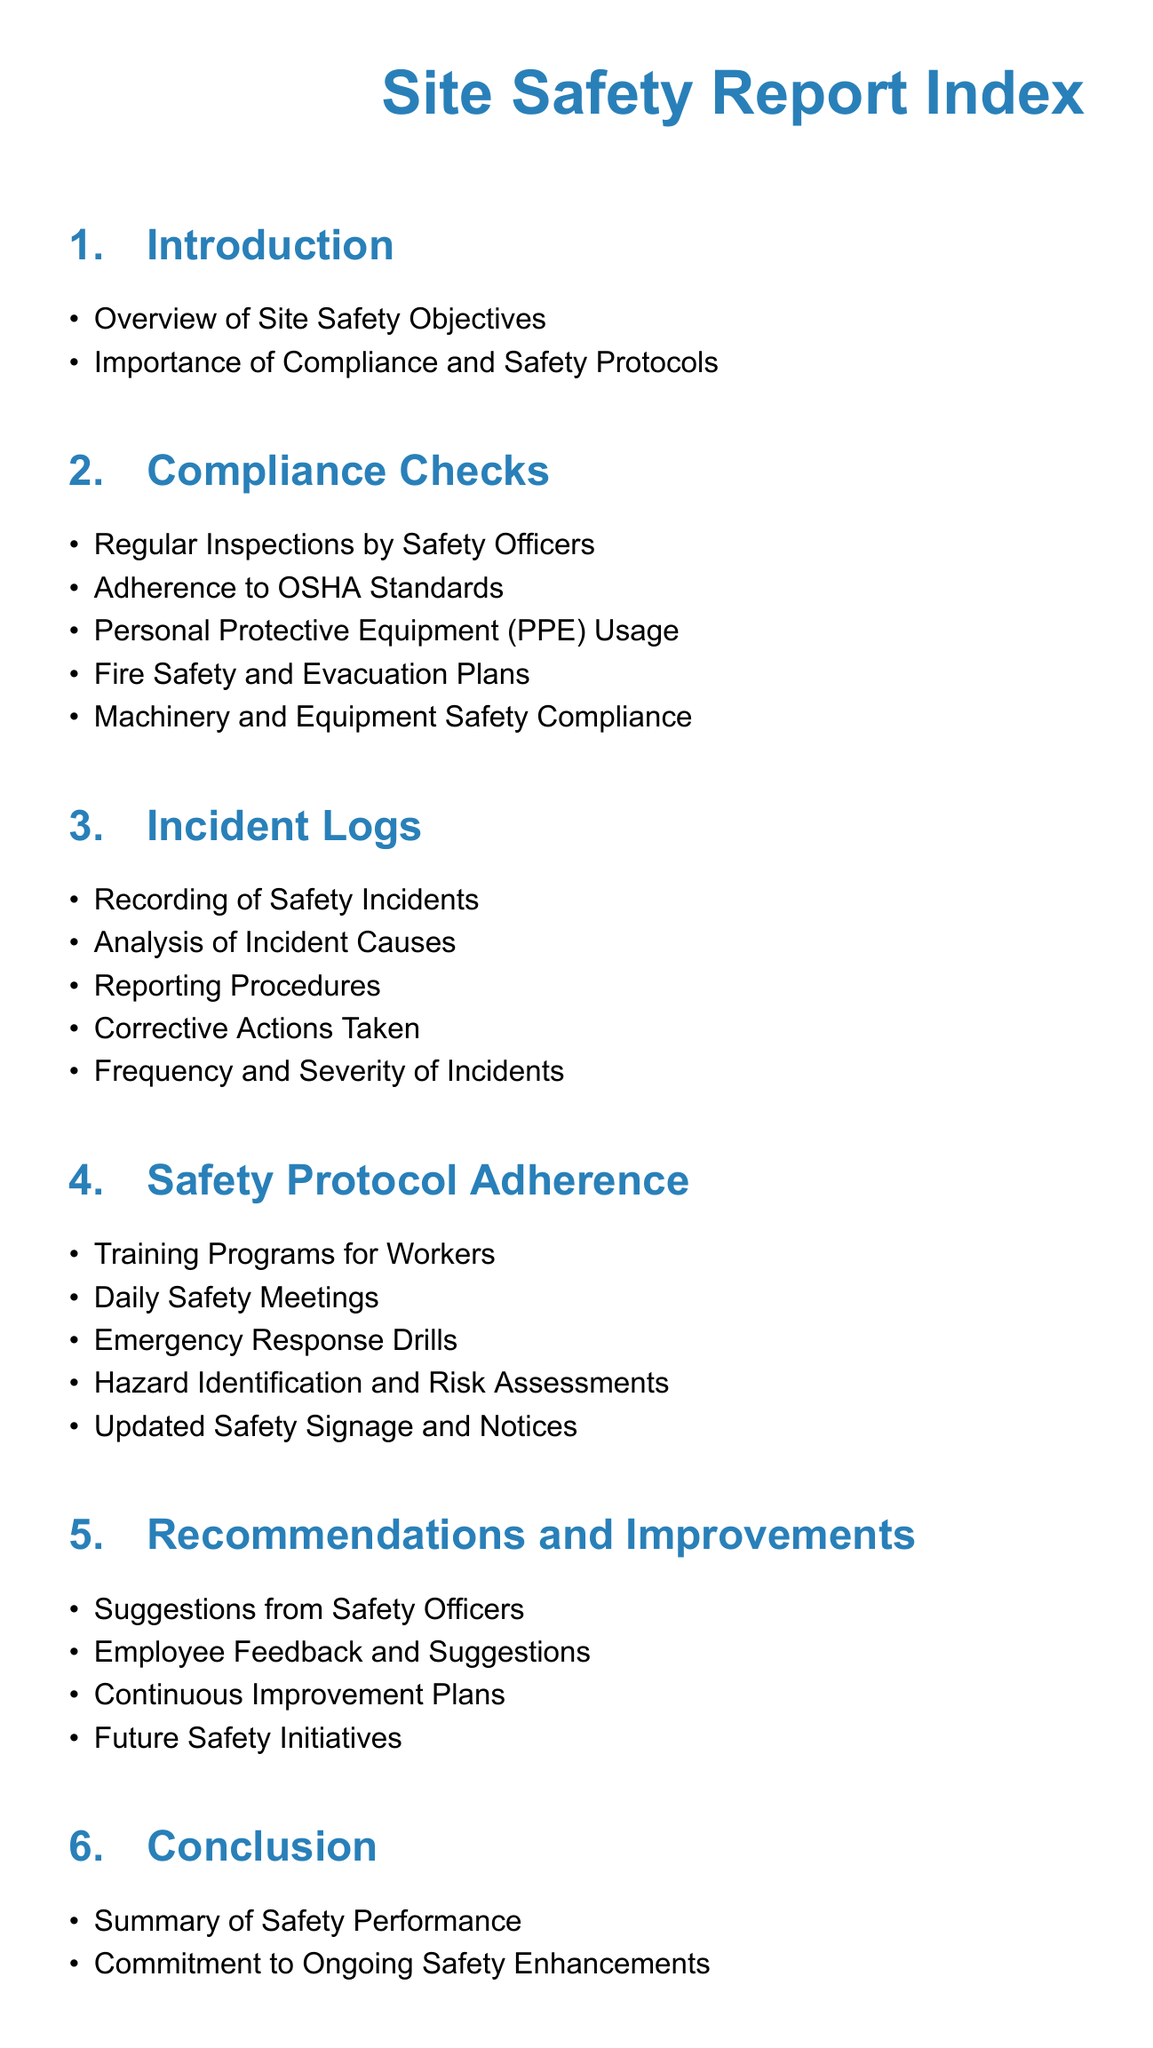What is the title of the document? The title is prominently displayed at the top of the document and is the first text seen.
Answer: Site Safety Report Index What section discusses the objectives of site safety? The section detailing the objectives is the first one after the introduction.
Answer: Introduction How many items are listed under Compliance Checks? The number of items can be counted in the Compliance Checks section.
Answer: Five What is included in Appendix A? The contents of Appendix A are explicitly stated in the list of appendices.
Answer: Inspection Checklists When are daily safety meetings mentioned? The mention of daily safety meetings can be found in the Safety Protocol Adherence section.
Answer: Safety Protocol Adherence What is one key part of the recommendations section? The key parts of the recommendations section can be identified by listing their contents.
Answer: Suggestions from Safety Officers What type of records are found in Appendix C? Appendix C clearly states the type of records included, which can be referenced directly.
Answer: Training Records How many sections are there in the report? By counting the number of main sections listed in the document, you can find the answer.
Answer: Six What ensures adherence to OSHA Standards? Compliance Checks section specifically addresses adherence to OSHA Standards.
Answer: Adherence to OSHA Standards 